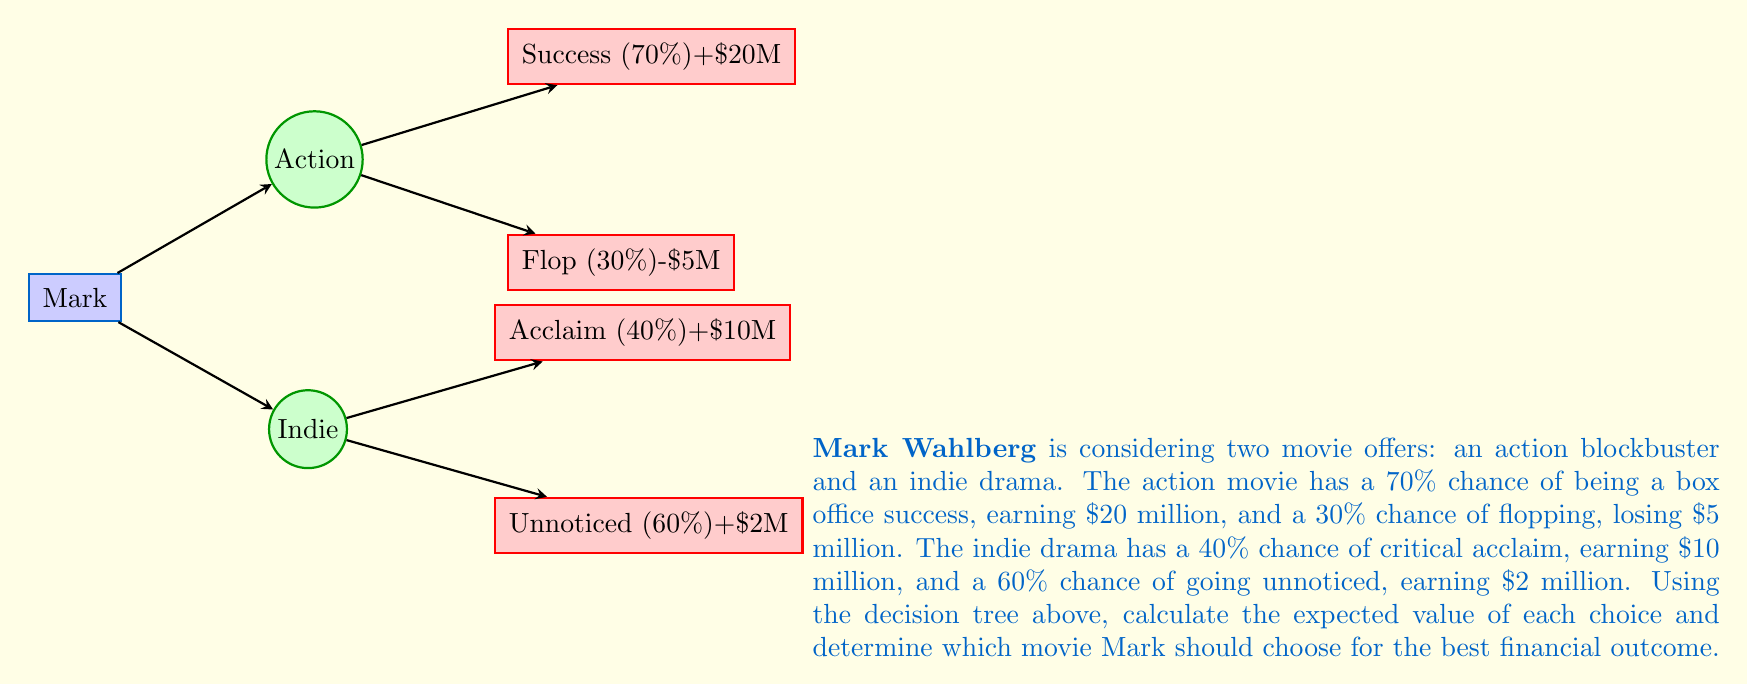Help me with this question. Let's calculate the expected value for each movie choice:

1. Action movie:
   - Success: $0.70 \times \$20M = \$14M$
   - Flop: $0.30 \times (-\$5M) = -\$1.5M$
   Expected value: $\$14M + (-\$1.5M) = \$12.5M$

2. Indie drama:
   - Critical acclaim: $0.40 \times \$10M = \$4M$
   - Unnoticed: $0.60 \times \$2M = \$1.2M$
   Expected value: $\$4M + \$1.2M = \$5.2M$

The expected value (EV) is calculated using the formula:

$$EV = \sum_{i=1}^{n} p_i \times v_i$$

Where $p_i$ is the probability of each outcome and $v_i$ is the value of that outcome.

For the action movie:
$$EV_{action} = (0.70 \times \$20M) + (0.30 \times (-\$5M)) = \$12.5M$$

For the indie drama:
$$EV_{indie} = (0.40 \times \$10M) + (0.60 \times \$2M) = \$5.2M$$

Since the expected value of the action movie (\$12.5M) is higher than the indie drama (\$5.2M), Mark should choose the action movie for the best financial outcome.
Answer: Action movie, $\$12.5M$ expected value 